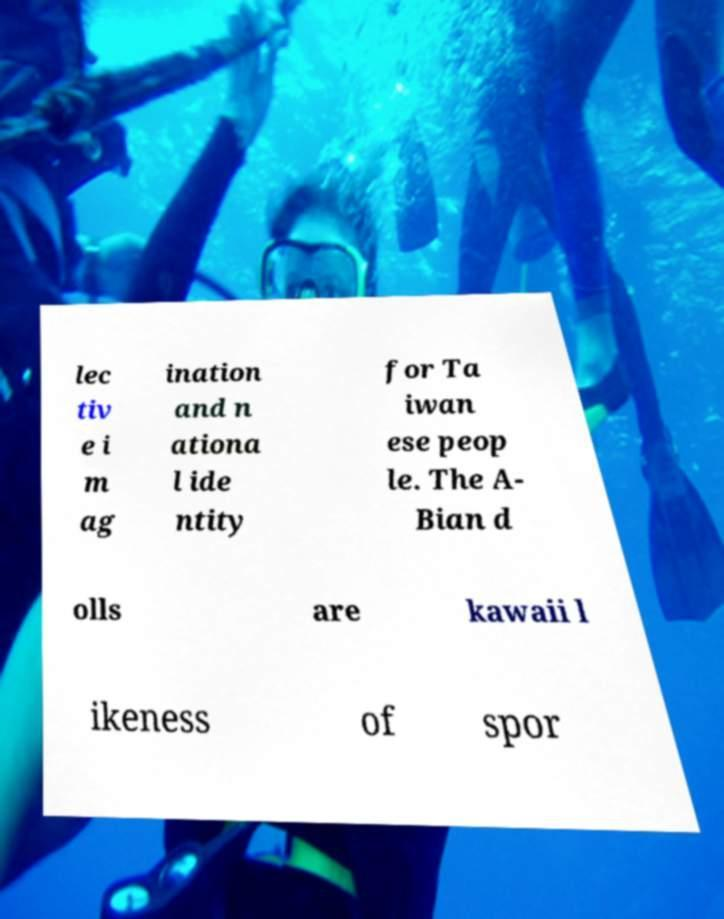Could you extract and type out the text from this image? lec tiv e i m ag ination and n ationa l ide ntity for Ta iwan ese peop le. The A- Bian d olls are kawaii l ikeness of spor 